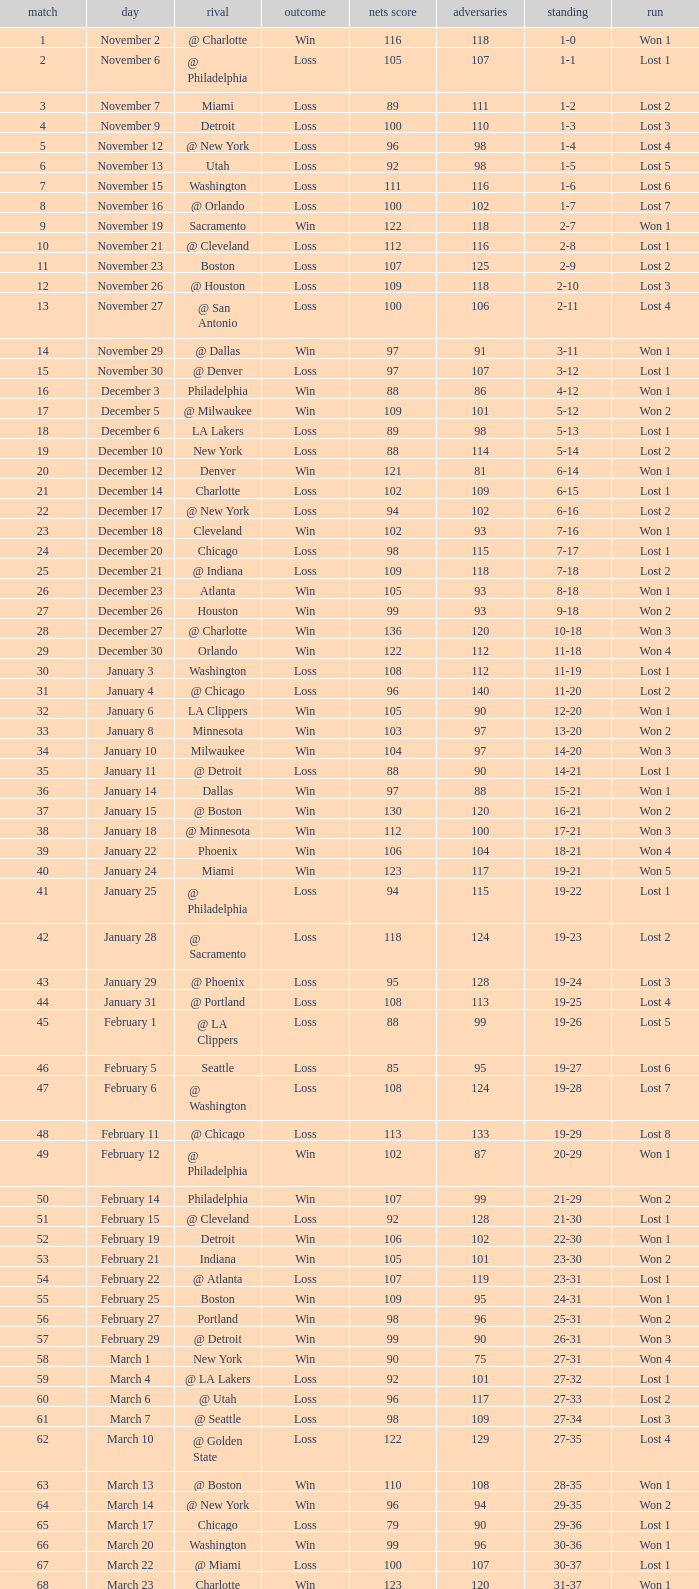How many games had fewer than 118 opponents and more than 109 net points with an opponent of Washington? 1.0. 